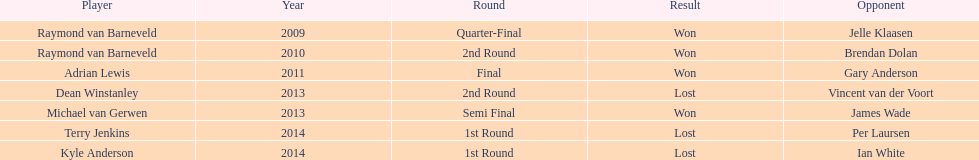Who are all the players? Raymond van Barneveld, Raymond van Barneveld, Adrian Lewis, Dean Winstanley, Michael van Gerwen, Terry Jenkins, Kyle Anderson. When did they play? 2009, 2010, 2011, 2013, 2013, 2014, 2014. And which player played in 2011? Adrian Lewis. 